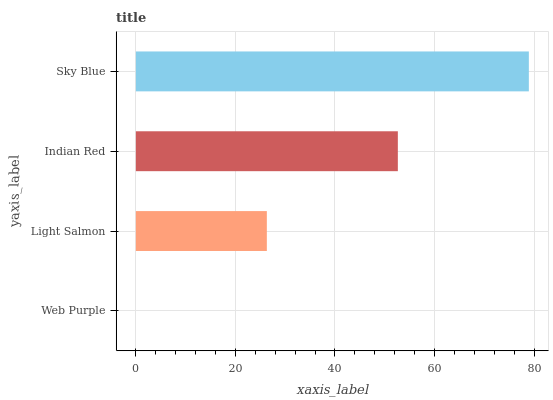Is Web Purple the minimum?
Answer yes or no. Yes. Is Sky Blue the maximum?
Answer yes or no. Yes. Is Light Salmon the minimum?
Answer yes or no. No. Is Light Salmon the maximum?
Answer yes or no. No. Is Light Salmon greater than Web Purple?
Answer yes or no. Yes. Is Web Purple less than Light Salmon?
Answer yes or no. Yes. Is Web Purple greater than Light Salmon?
Answer yes or no. No. Is Light Salmon less than Web Purple?
Answer yes or no. No. Is Indian Red the high median?
Answer yes or no. Yes. Is Light Salmon the low median?
Answer yes or no. Yes. Is Sky Blue the high median?
Answer yes or no. No. Is Web Purple the low median?
Answer yes or no. No. 